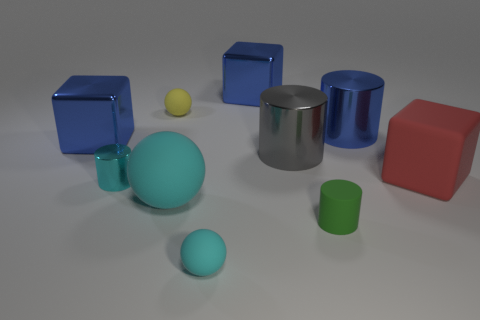What is the texture of the surface on which the objects are placed? The objects are placed on a smooth, matte surface that appears to have a slight texture or grain, likely a synthetic material or coated finish. The matte quality of the surface ensures that there are no reflections from it, which helps to focus attention on the objects themselves. 